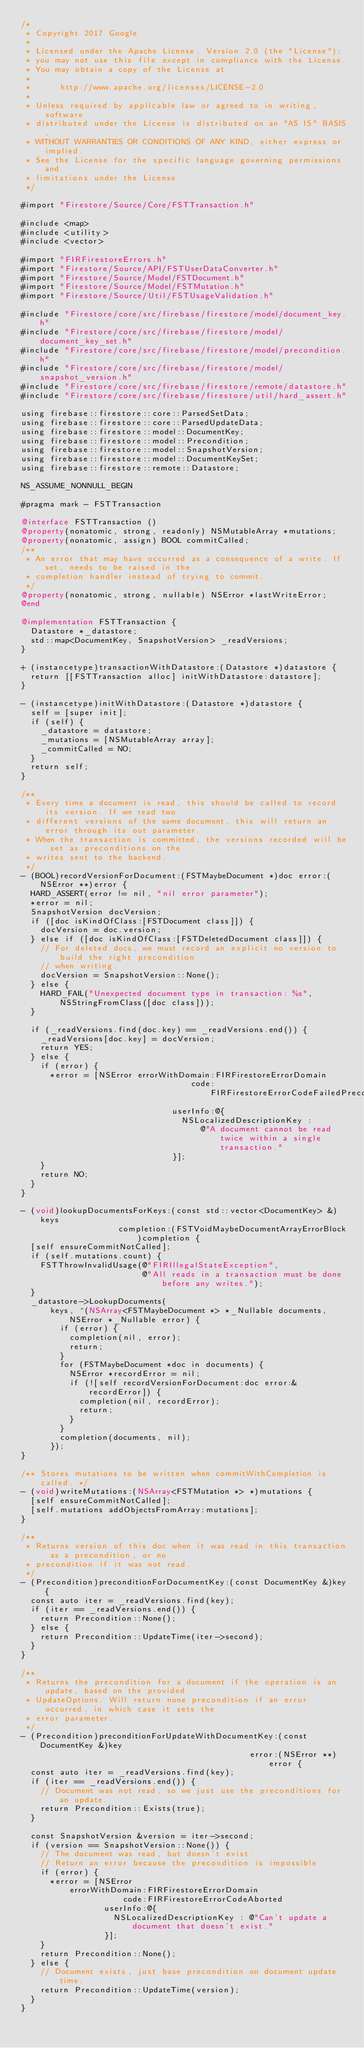<code> <loc_0><loc_0><loc_500><loc_500><_ObjectiveC_>/*
 * Copyright 2017 Google
 *
 * Licensed under the Apache License, Version 2.0 (the "License");
 * you may not use this file except in compliance with the License.
 * You may obtain a copy of the License at
 *
 *      http://www.apache.org/licenses/LICENSE-2.0
 *
 * Unless required by applicable law or agreed to in writing, software
 * distributed under the License is distributed on an "AS IS" BASIS,
 * WITHOUT WARRANTIES OR CONDITIONS OF ANY KIND, either express or implied.
 * See the License for the specific language governing permissions and
 * limitations under the License.
 */

#import "Firestore/Source/Core/FSTTransaction.h"

#include <map>
#include <utility>
#include <vector>

#import "FIRFirestoreErrors.h"
#import "Firestore/Source/API/FSTUserDataConverter.h"
#import "Firestore/Source/Model/FSTDocument.h"
#import "Firestore/Source/Model/FSTMutation.h"
#import "Firestore/Source/Util/FSTUsageValidation.h"

#include "Firestore/core/src/firebase/firestore/model/document_key.h"
#include "Firestore/core/src/firebase/firestore/model/document_key_set.h"
#include "Firestore/core/src/firebase/firestore/model/precondition.h"
#include "Firestore/core/src/firebase/firestore/model/snapshot_version.h"
#include "Firestore/core/src/firebase/firestore/remote/datastore.h"
#include "Firestore/core/src/firebase/firestore/util/hard_assert.h"

using firebase::firestore::core::ParsedSetData;
using firebase::firestore::core::ParsedUpdateData;
using firebase::firestore::model::DocumentKey;
using firebase::firestore::model::Precondition;
using firebase::firestore::model::SnapshotVersion;
using firebase::firestore::model::DocumentKeySet;
using firebase::firestore::remote::Datastore;

NS_ASSUME_NONNULL_BEGIN

#pragma mark - FSTTransaction

@interface FSTTransaction ()
@property(nonatomic, strong, readonly) NSMutableArray *mutations;
@property(nonatomic, assign) BOOL commitCalled;
/**
 * An error that may have occurred as a consequence of a write. If set, needs to be raised in the
 * completion handler instead of trying to commit.
 */
@property(nonatomic, strong, nullable) NSError *lastWriteError;
@end

@implementation FSTTransaction {
  Datastore *_datastore;
  std::map<DocumentKey, SnapshotVersion> _readVersions;
}

+ (instancetype)transactionWithDatastore:(Datastore *)datastore {
  return [[FSTTransaction alloc] initWithDatastore:datastore];
}

- (instancetype)initWithDatastore:(Datastore *)datastore {
  self = [super init];
  if (self) {
    _datastore = datastore;
    _mutations = [NSMutableArray array];
    _commitCalled = NO;
  }
  return self;
}

/**
 * Every time a document is read, this should be called to record its version. If we read two
 * different versions of the same document, this will return an error through its out parameter.
 * When the transaction is committed, the versions recorded will be set as preconditions on the
 * writes sent to the backend.
 */
- (BOOL)recordVersionForDocument:(FSTMaybeDocument *)doc error:(NSError **)error {
  HARD_ASSERT(error != nil, "nil error parameter");
  *error = nil;
  SnapshotVersion docVersion;
  if ([doc isKindOfClass:[FSTDocument class]]) {
    docVersion = doc.version;
  } else if ([doc isKindOfClass:[FSTDeletedDocument class]]) {
    // For deleted docs, we must record an explicit no version to build the right precondition
    // when writing.
    docVersion = SnapshotVersion::None();
  } else {
    HARD_FAIL("Unexpected document type in transaction: %s", NSStringFromClass([doc class]));
  }

  if (_readVersions.find(doc.key) == _readVersions.end()) {
    _readVersions[doc.key] = docVersion;
    return YES;
  } else {
    if (error) {
      *error = [NSError errorWithDomain:FIRFirestoreErrorDomain
                                   code:FIRFirestoreErrorCodeFailedPrecondition
                               userInfo:@{
                                 NSLocalizedDescriptionKey :
                                     @"A document cannot be read twice within a single transaction."
                               }];
    }
    return NO;
  }
}

- (void)lookupDocumentsForKeys:(const std::vector<DocumentKey> &)keys
                    completion:(FSTVoidMaybeDocumentArrayErrorBlock)completion {
  [self ensureCommitNotCalled];
  if (self.mutations.count) {
    FSTThrowInvalidUsage(@"FIRIllegalStateException",
                         @"All reads in a transaction must be done before any writes.");
  }
  _datastore->LookupDocuments(
      keys, ^(NSArray<FSTMaybeDocument *> *_Nullable documents, NSError *_Nullable error) {
        if (error) {
          completion(nil, error);
          return;
        }
        for (FSTMaybeDocument *doc in documents) {
          NSError *recordError = nil;
          if (![self recordVersionForDocument:doc error:&recordError]) {
            completion(nil, recordError);
            return;
          }
        }
        completion(documents, nil);
      });
}

/** Stores mutations to be written when commitWithCompletion is called. */
- (void)writeMutations:(NSArray<FSTMutation *> *)mutations {
  [self ensureCommitNotCalled];
  [self.mutations addObjectsFromArray:mutations];
}

/**
 * Returns version of this doc when it was read in this transaction as a precondition, or no
 * precondition if it was not read.
 */
- (Precondition)preconditionForDocumentKey:(const DocumentKey &)key {
  const auto iter = _readVersions.find(key);
  if (iter == _readVersions.end()) {
    return Precondition::None();
  } else {
    return Precondition::UpdateTime(iter->second);
  }
}

/**
 * Returns the precondition for a document if the operation is an update, based on the provided
 * UpdateOptions. Will return none precondition if an error occurred, in which case it sets the
 * error parameter.
 */
- (Precondition)preconditionForUpdateWithDocumentKey:(const DocumentKey &)key
                                               error:(NSError **)error {
  const auto iter = _readVersions.find(key);
  if (iter == _readVersions.end()) {
    // Document was not read, so we just use the preconditions for an update.
    return Precondition::Exists(true);
  }

  const SnapshotVersion &version = iter->second;
  if (version == SnapshotVersion::None()) {
    // The document was read, but doesn't exist.
    // Return an error because the precondition is impossible
    if (error) {
      *error = [NSError
          errorWithDomain:FIRFirestoreErrorDomain
                     code:FIRFirestoreErrorCodeAborted
                 userInfo:@{
                   NSLocalizedDescriptionKey : @"Can't update a document that doesn't exist."
                 }];
    }
    return Precondition::None();
  } else {
    // Document exists, just base precondition on document update time.
    return Precondition::UpdateTime(version);
  }
}
</code> 